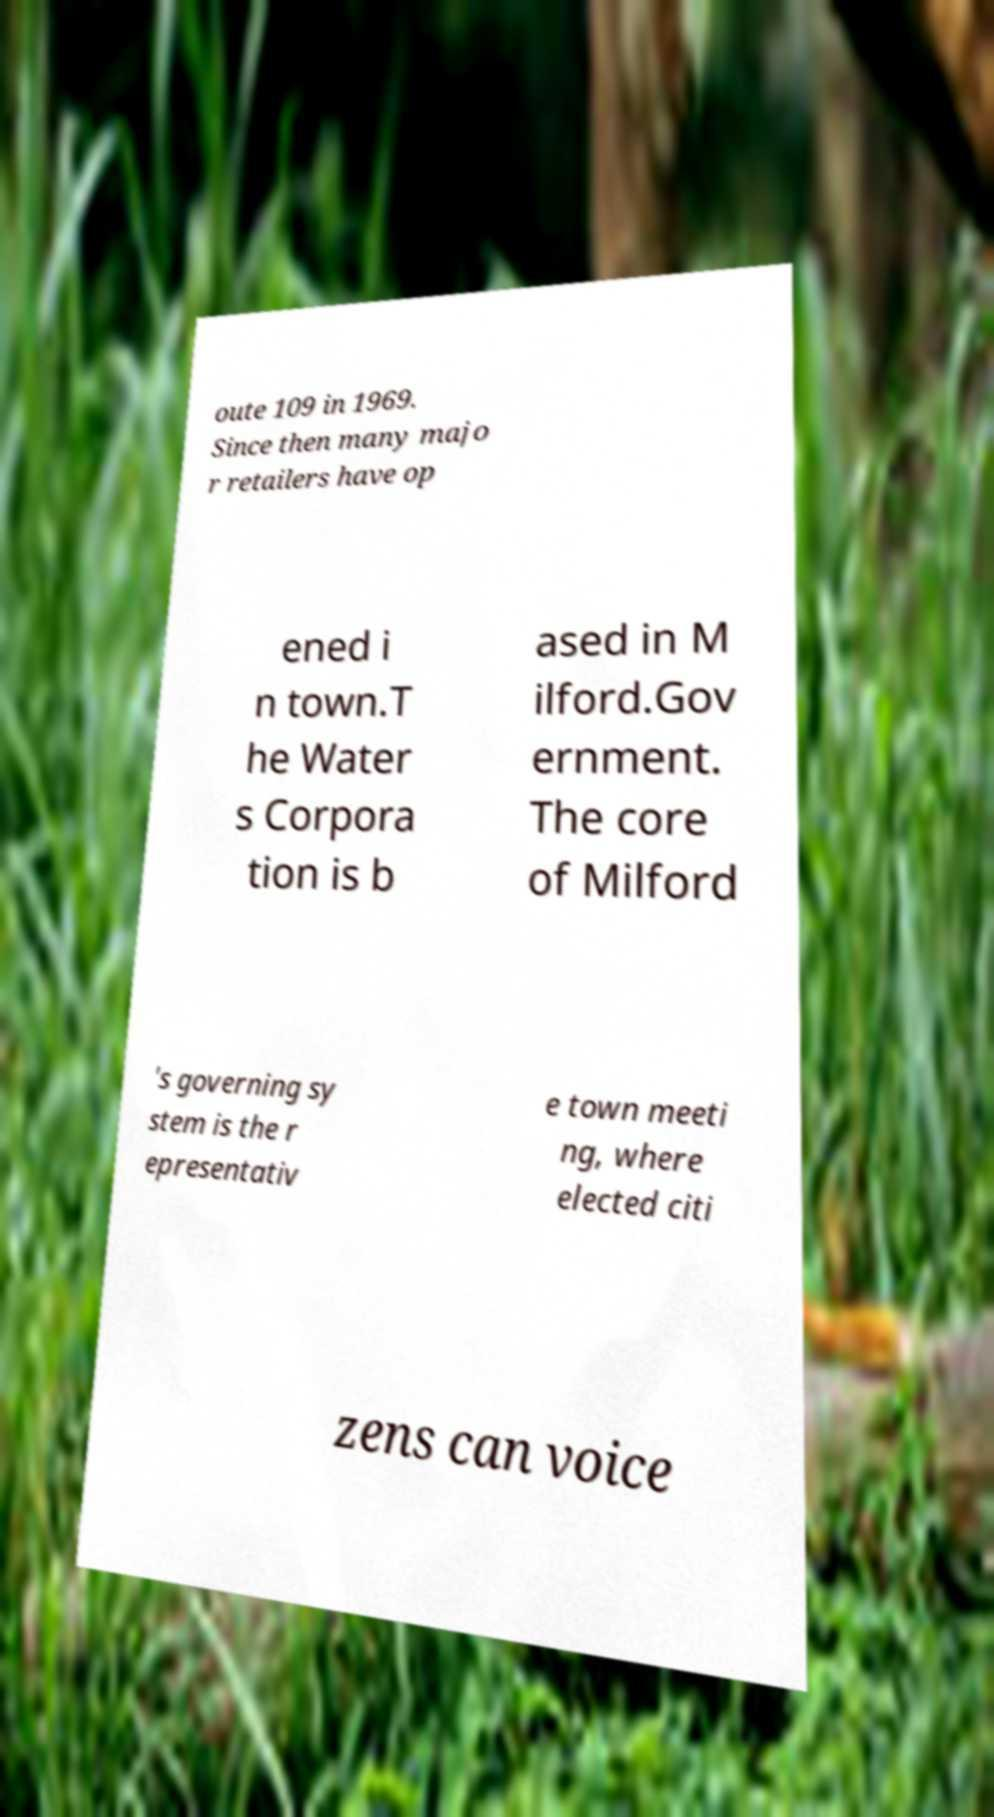There's text embedded in this image that I need extracted. Can you transcribe it verbatim? oute 109 in 1969. Since then many majo r retailers have op ened i n town.T he Water s Corpora tion is b ased in M ilford.Gov ernment. The core of Milford 's governing sy stem is the r epresentativ e town meeti ng, where elected citi zens can voice 